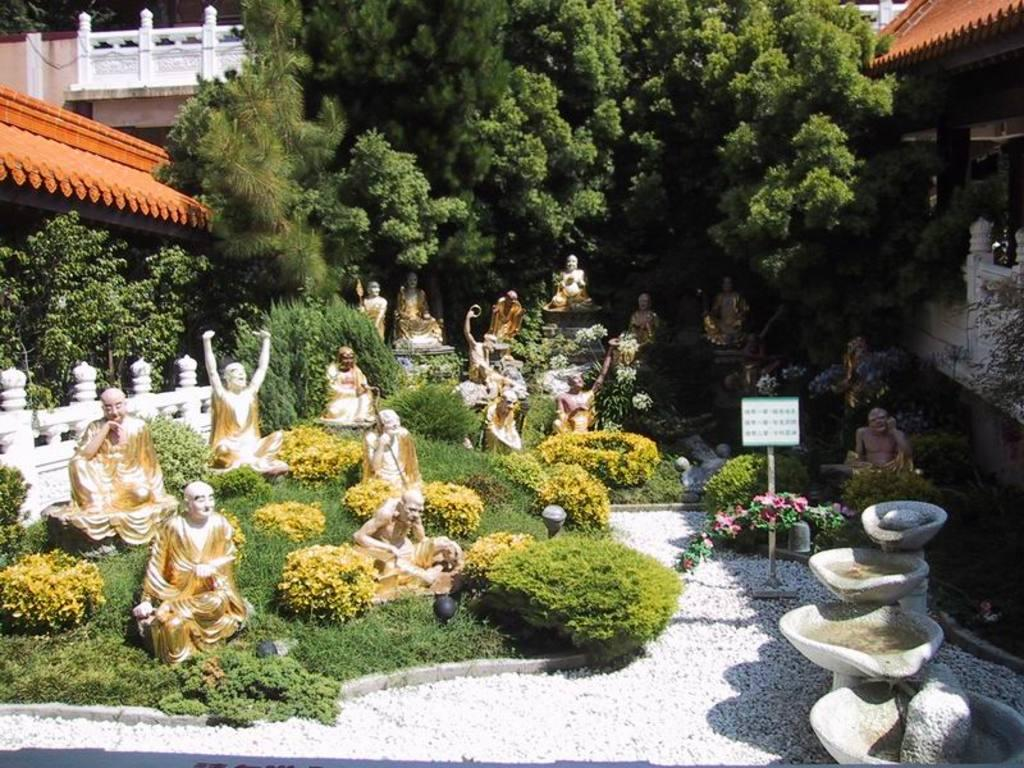What type of objects can be seen in the image? There are statues in the image. What type of vegetation is present in the image? There is grass, small plants, and trees visible in the image. What type of material is present in the image? Stones are present in the image. What type of structures can be seen in the image? There are buildings in the image. Can you tell me the size of the pocket in the image? There is no pocket present in the image. What type of property is visible in the image? The image does not show any property; it features statues, grass, small plants, trees, stones, and buildings. 